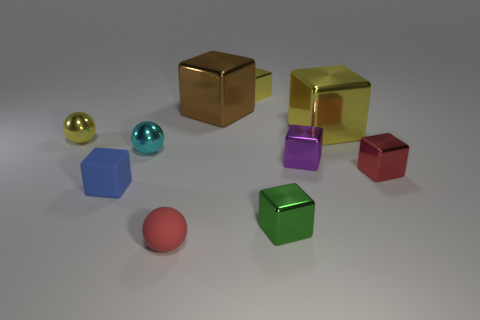What is the shape of the small red object that is in front of the red object behind the rubber thing that is behind the tiny green metallic cube?
Offer a very short reply. Sphere. There is a tiny thing that is the same color as the tiny matte ball; what shape is it?
Your answer should be very brief. Cube. What number of things are either small yellow objects or objects that are left of the big brown cube?
Offer a very short reply. 5. Is the size of the metal thing in front of the red block the same as the small blue matte cube?
Ensure brevity in your answer.  Yes. What is the cube that is in front of the small blue cube made of?
Keep it short and to the point. Metal. Are there an equal number of purple metallic objects that are left of the green block and tiny red metallic blocks in front of the red sphere?
Ensure brevity in your answer.  Yes. What is the color of the matte object that is the same shape as the tiny red metal thing?
Your answer should be compact. Blue. Is there anything else that has the same color as the matte block?
Make the answer very short. No. How many shiny objects are small yellow spheres or small red objects?
Provide a succinct answer. 2. Does the tiny matte block have the same color as the small rubber ball?
Your response must be concise. No. 